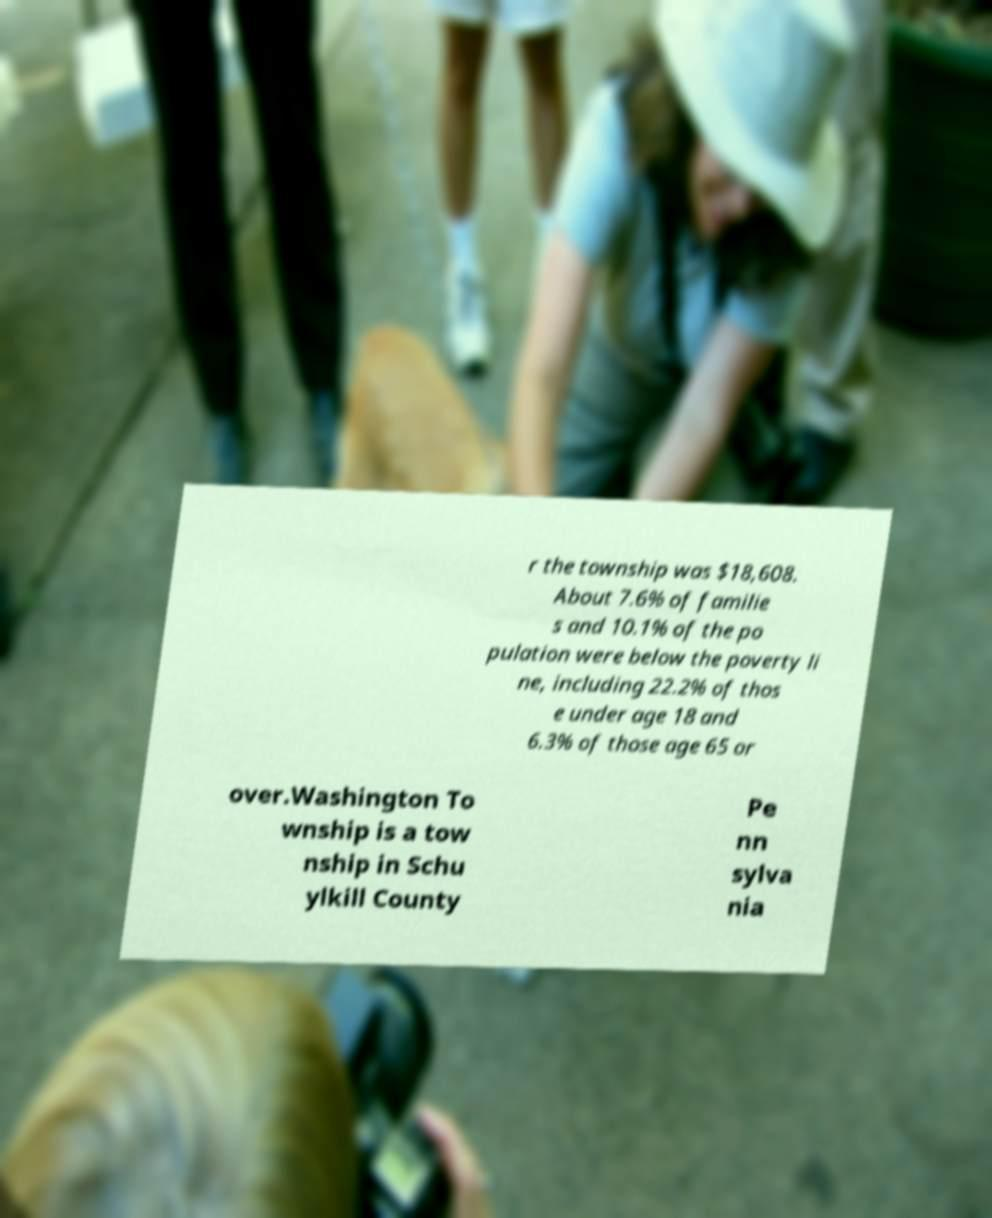What messages or text are displayed in this image? I need them in a readable, typed format. r the township was $18,608. About 7.6% of familie s and 10.1% of the po pulation were below the poverty li ne, including 22.2% of thos e under age 18 and 6.3% of those age 65 or over.Washington To wnship is a tow nship in Schu ylkill County Pe nn sylva nia 